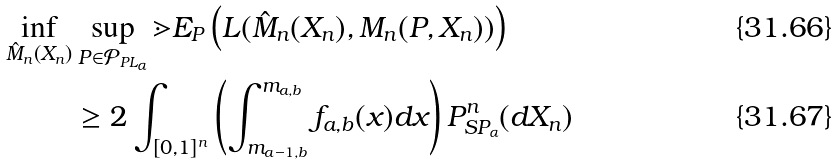Convert formula to latex. <formula><loc_0><loc_0><loc_500><loc_500>\inf _ { \hat { M } _ { n } ( X _ { n } ) } & \sup _ { P \in \mathcal { P } _ { P L _ { \alpha } } } \mathbb { m } { E } _ { P } \left ( L ( \hat { M } _ { n } ( X _ { n } ) , M _ { n } ( P , X _ { n } ) ) \right ) \\ & \geq 2 \int _ { [ 0 , 1 ] ^ { n } } \left ( \int _ { m _ { a - 1 , b } } ^ { m _ { a , b } } f _ { a , b } ( x ) d x \right ) P ^ { n } _ { S P _ { \alpha } } ( d X _ { n } )</formula> 